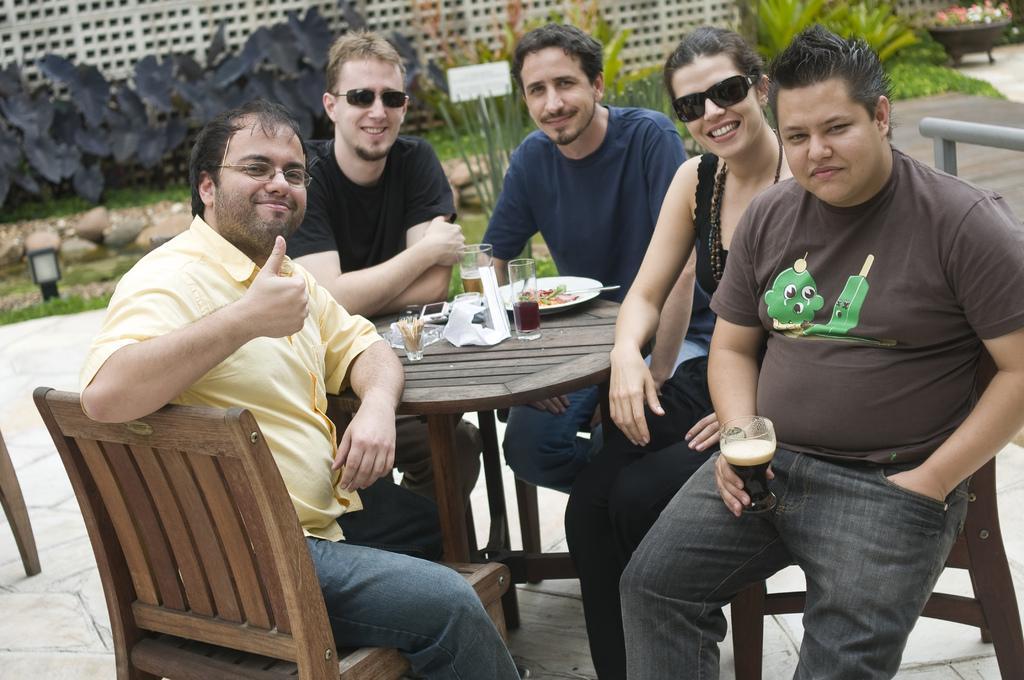Can you describe this image briefly? There are four men and one women sitting on the chairs and smiling. This is a wooden table with plate,glasses ,mobile phone and few other things on it. At background I can see small plants. These are the rocks. I think this is the light. 